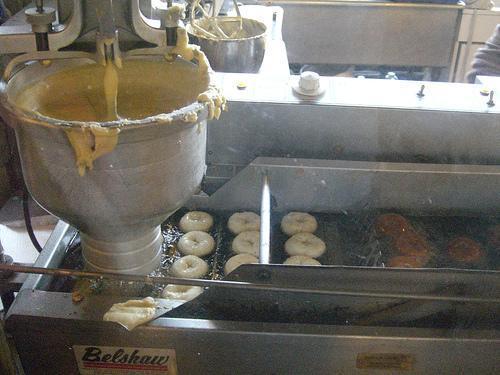How many already fried donuts are there in the image?
Give a very brief answer. 4. 